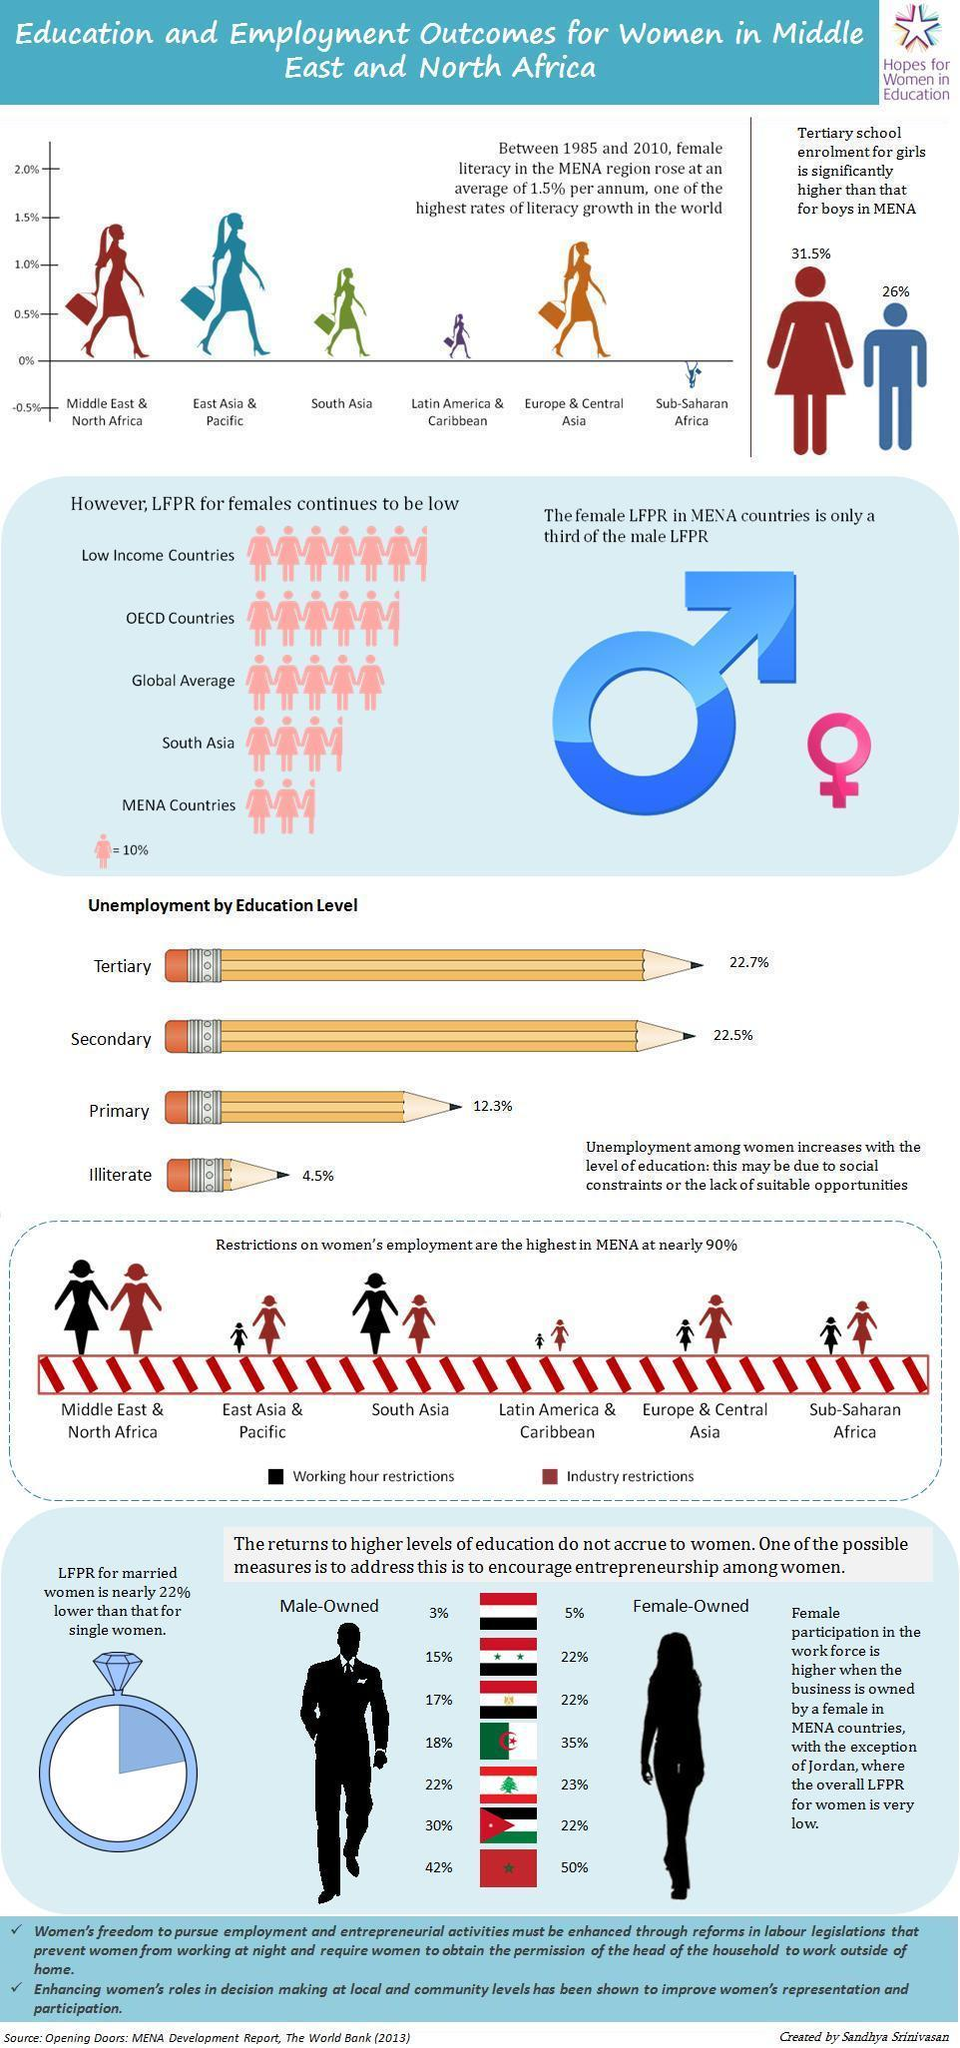LFPR for females is 50% for which region?
Answer the question with a short phrase. global average Which region in the graph shows the second highest female literacy growth rate? Middle East & North Africa In which region are industry restrictions lowest for women? Latin America & Caribbean Working hour restrictions for women are the least in which region? Latin America & Caribbean What is the tertiary school enrolment percentage for girls in MENA? 31.5% What is the tertiary school enrolment percentage for boys in MENA? 26% Which region has the second highest LFPR for women? OECD countries In the graph, which region shows a negative trend in female literacy growth? Sub-Saharan Africa Which region in the graph shows highest female literacy growth rate? East Asia & Pacific Which region has the second lowest LFPR for women? South Asia 